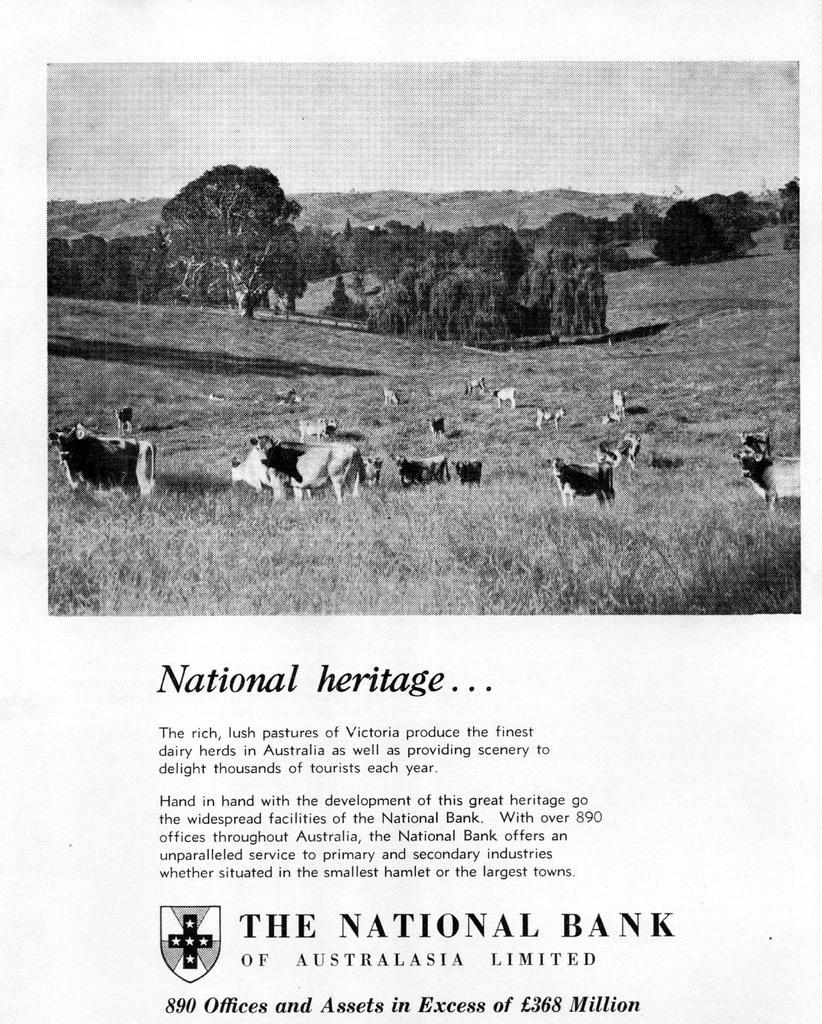Could you give a brief overview of what you see in this image? Picture of a page. Something written on this page. In this image we can see animals and trees. 